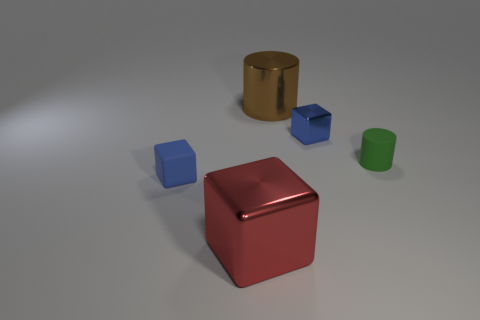What can you infer about the lighting in the scene? The shadows and highlights on the objects suggest that there is a single diffuse light source coming from the upper left side of the scene. The light casting is soft, creating gentle shadows, which implies that the environment could be an indoor setting with a softbox or window light source. 